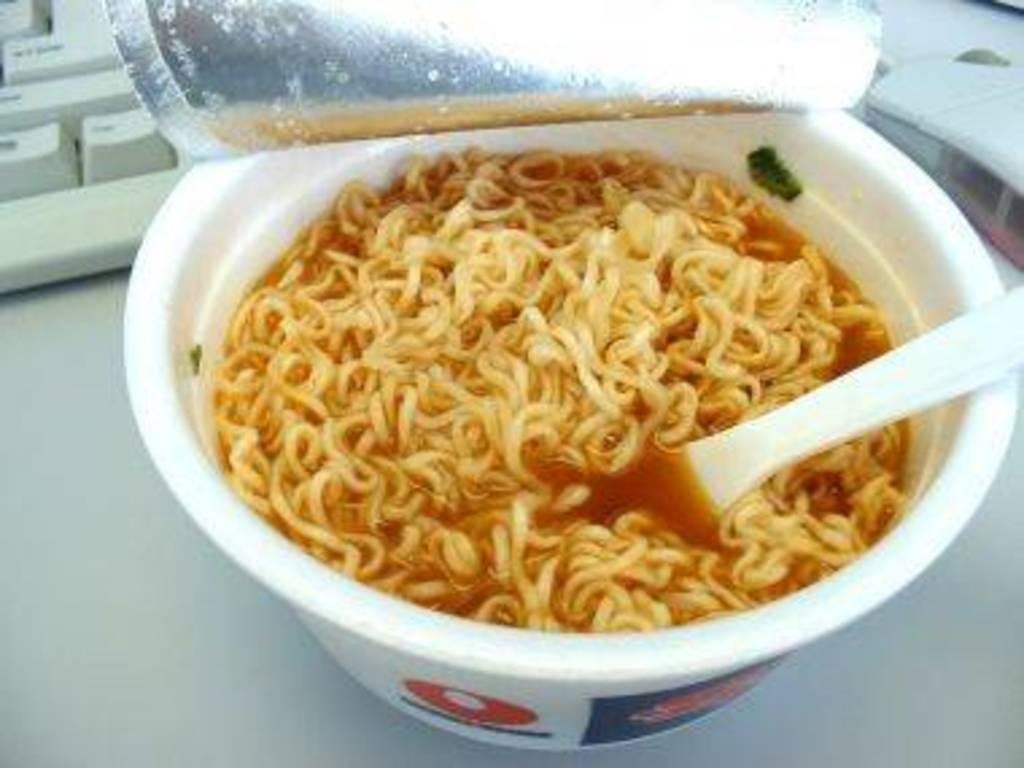What type of food is in the cup that is visible in the image? There is a cup of noodles in the image. What utensil is present in the image? There is a spoon in the image. What type of device is in the image? There is a keyboard in the image. What is the small, handheld object in the image? There is a mouse in the image. Where are all these objects located in the image? All these objects are on a table. What type of scale is used to weigh the noodles in the image? There is no scale present in the image; it only shows a cup of noodles, a spoon, a keyboard, a mouse, and a table. 